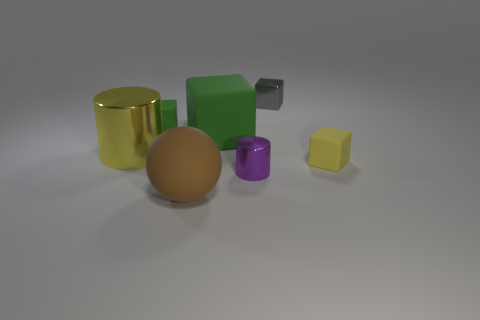Subtract all purple blocks. Subtract all green cylinders. How many blocks are left? 4 Add 2 small metal blocks. How many objects exist? 9 Subtract all cylinders. How many objects are left? 5 Add 7 yellow objects. How many yellow objects exist? 9 Subtract 0 red balls. How many objects are left? 7 Subtract all large brown things. Subtract all tiny yellow cubes. How many objects are left? 5 Add 1 large yellow cylinders. How many large yellow cylinders are left? 2 